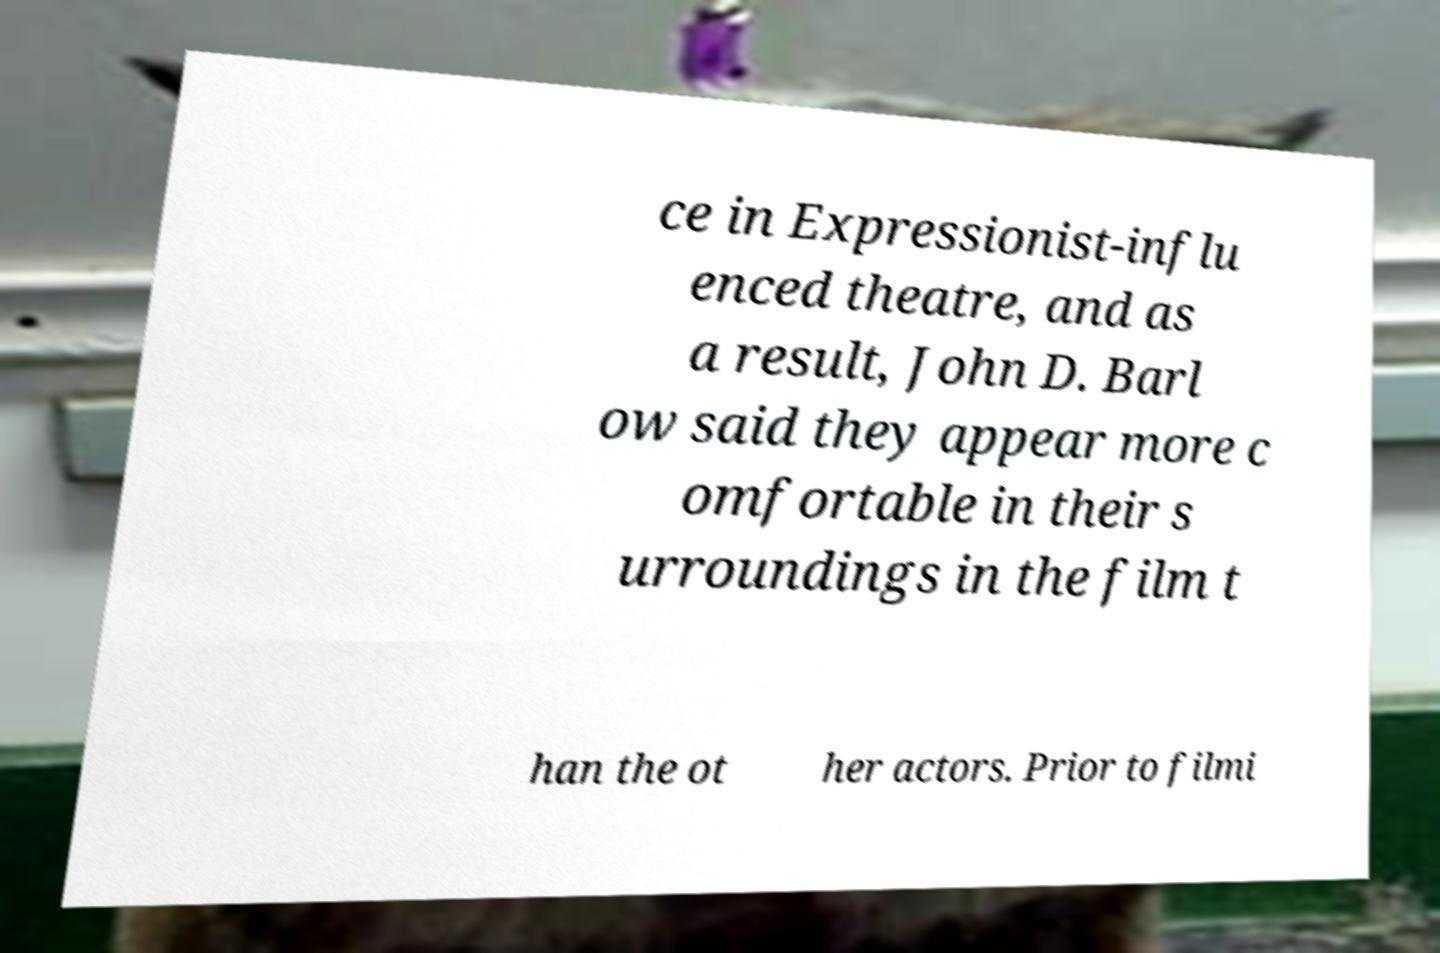What messages or text are displayed in this image? I need them in a readable, typed format. ce in Expressionist-influ enced theatre, and as a result, John D. Barl ow said they appear more c omfortable in their s urroundings in the film t han the ot her actors. Prior to filmi 